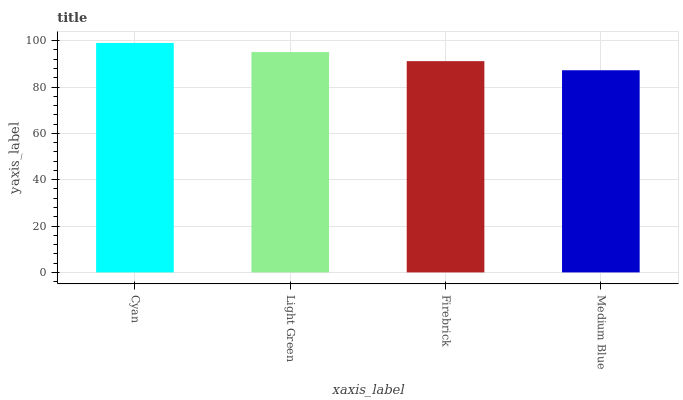Is Medium Blue the minimum?
Answer yes or no. Yes. Is Cyan the maximum?
Answer yes or no. Yes. Is Light Green the minimum?
Answer yes or no. No. Is Light Green the maximum?
Answer yes or no. No. Is Cyan greater than Light Green?
Answer yes or no. Yes. Is Light Green less than Cyan?
Answer yes or no. Yes. Is Light Green greater than Cyan?
Answer yes or no. No. Is Cyan less than Light Green?
Answer yes or no. No. Is Light Green the high median?
Answer yes or no. Yes. Is Firebrick the low median?
Answer yes or no. Yes. Is Medium Blue the high median?
Answer yes or no. No. Is Medium Blue the low median?
Answer yes or no. No. 